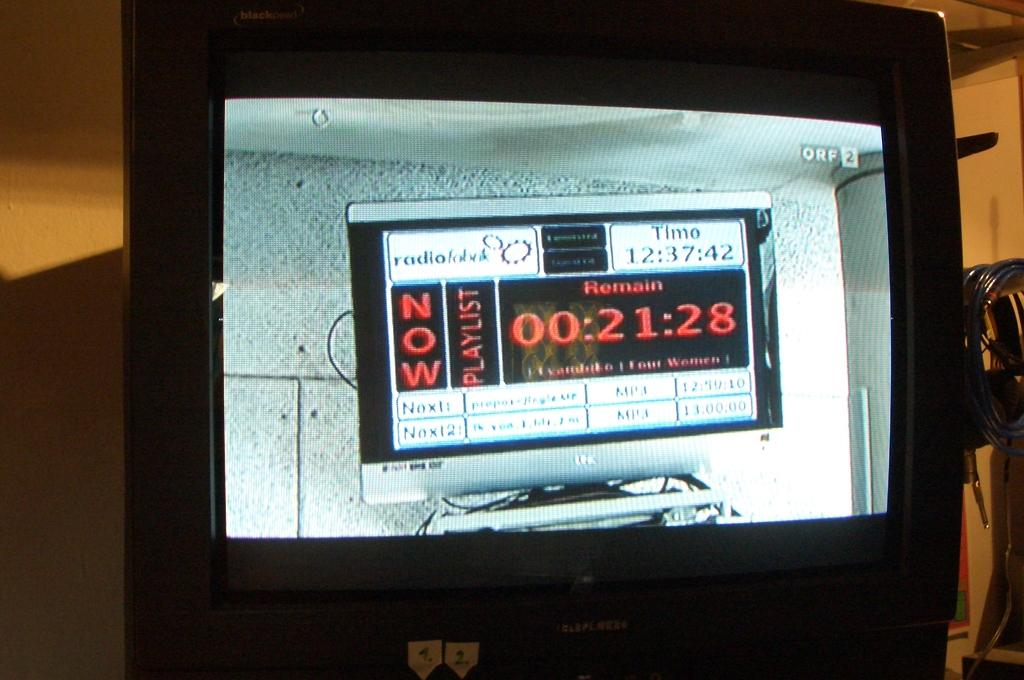<image>
Describe the image concisely. A screen has a display showing the time as 12:37:42. 